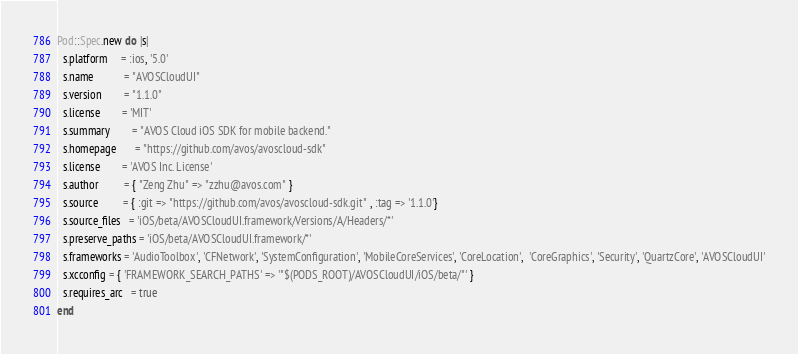<code> <loc_0><loc_0><loc_500><loc_500><_Ruby_>Pod::Spec.new do |s|
  s.platform     = :ios, '5.0'
  s.name           = "AVOSCloudUI"
  s.version        = "1.1.0"
  s.license        = 'MIT'  
  s.summary        = "AVOS Cloud iOS SDK for mobile backend."
  s.homepage       = "https://github.com/avos/avoscloud-sdk"
  s.license        = 'AVOS Inc. License'
  s.author         = { "Zeng Zhu" => "zzhu@avos.com" }
  s.source         = { :git => "https://github.com/avos/avoscloud-sdk.git" , :tag => '1.1.0'}
  s.source_files   = 'iOS/beta/AVOSCloudUI.framework/Versions/A/Headers/*'
  s.preserve_paths = 'iOS/beta/AVOSCloudUI.framework/*'
  s.frameworks = 'AudioToolbox', 'CFNetwork', 'SystemConfiguration', 'MobileCoreServices', 'CoreLocation',  'CoreGraphics', 'Security', 'QuartzCore', 'AVOSCloudUI'
  s.xcconfig = { 'FRAMEWORK_SEARCH_PATHS' => '"$(PODS_ROOT)/AVOSCloudUI/iOS/beta/"' }
  s.requires_arc   = true
end
</code> 